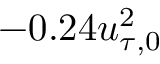Convert formula to latex. <formula><loc_0><loc_0><loc_500><loc_500>- 0 . 2 4 u _ { \tau , 0 } ^ { 2 }</formula> 